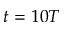<formula> <loc_0><loc_0><loc_500><loc_500>t = 1 0 T</formula> 